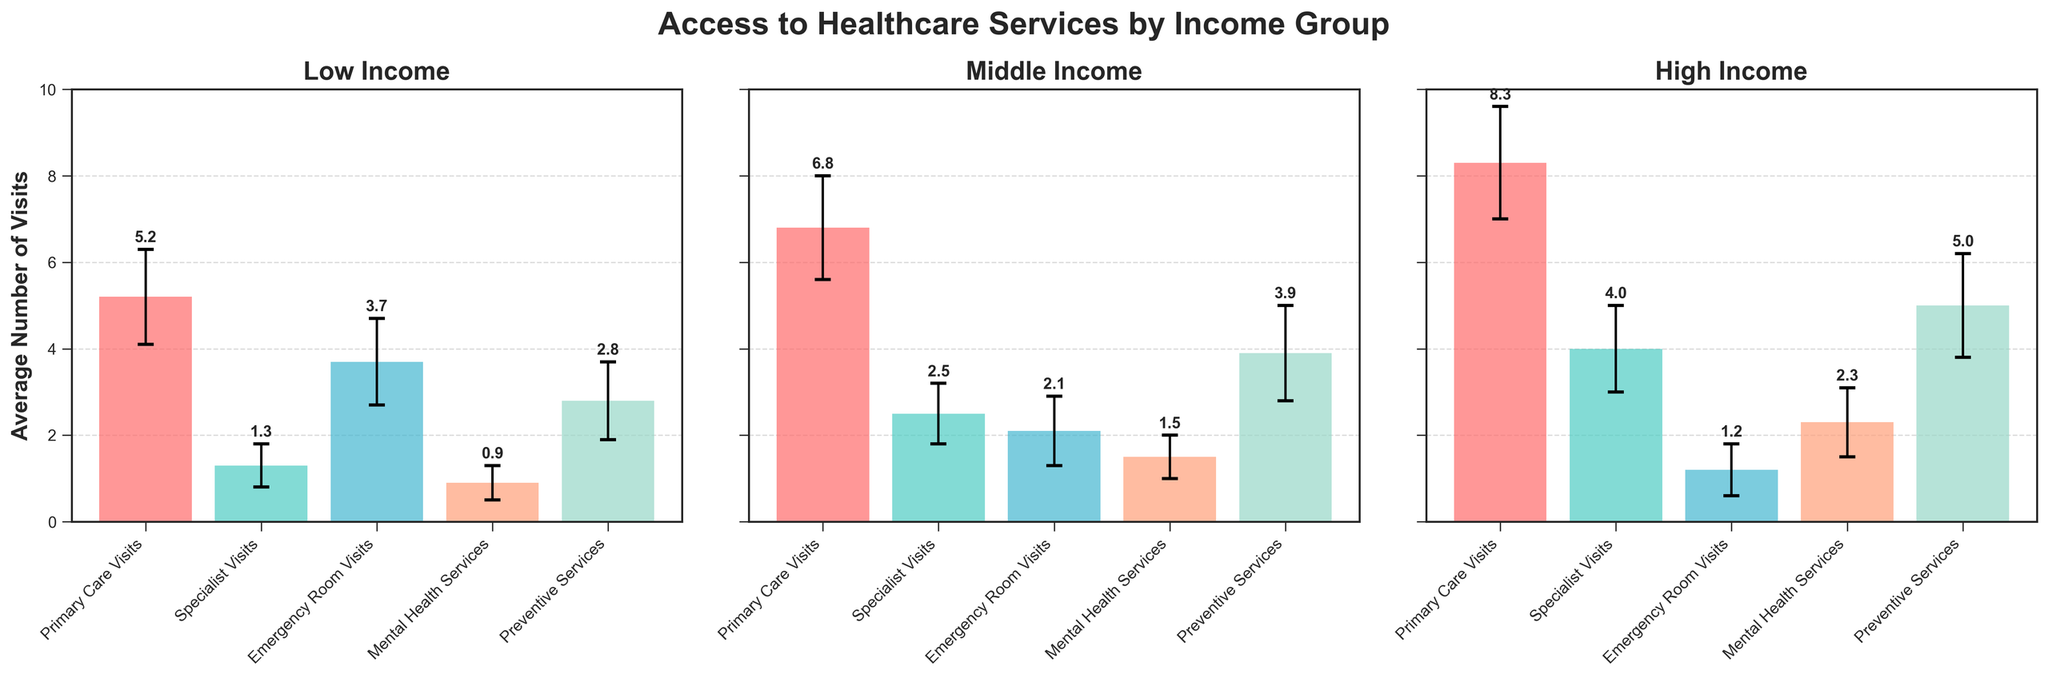How many healthcare services are presented in each subplot? There are five types of healthcare services presented: Primary Care Visits, Specialist Visits, Emergency Room Visits, Mental Health Services, and Preventive Services. This can be seen by counting the bars in each subplot.
Answer: 5 Which income group has the highest mean value for Primary Care Visits? The subplot titles indicate the different income groups. By comparing the height of the bars for Primary Care Visits across the subplots, the High Income group has the highest bar for Primary Care Visits.
Answer: High Income What is the mean number of Mental Health Services visits for the Middle Income group? The mean value for Mental Health Services visits for the Middle Income group can be found by looking at the corresponding bar height labeled within the Middle Income subplot. The value is 1.5.
Answer: 1.5 Which income group has the smallest standard deviation for Specialist Visits? By examining the error bars for Specialist Visits across the subplots, the Low Income group has the smallest standard deviation as it has the shortest error bar.
Answer: Low Income How much greater is the mean number of Emergency Room Visits for the Low Income group compared to the High Income group? The mean number of Emergency Room Visits for the Low Income group is 3.7 and for the High Income group is 1.2. The difference is calculated by subtracting 1.2 from 3.7.
Answer: 2.5 Which income group has the most consistent access to healthcare services in terms of lower standard deviations across all services? By examining the length of the error bars across all services for each income group, the group with the shortest overall error bars suggests more consistency. The High Income group generally has shorter error bars across all services.
Answer: High Income For which healthcare service is the disparity in mean access between income groups the greatest? Looking at the heights of the bars across the subplots for each healthcare service, Specialist Visits show the greatest disparity, with mean values going from 1.3 (Low Income) to 4.0 (High Income).
Answer: Specialist Visits What is the total mean number of Preventive Services visits across all income groups? Add the mean values for Preventive Services from each income group: 2.8 (Low Income) + 3.9 (Middle Income) + 5.0 (High Income).
Answer: 11.7 